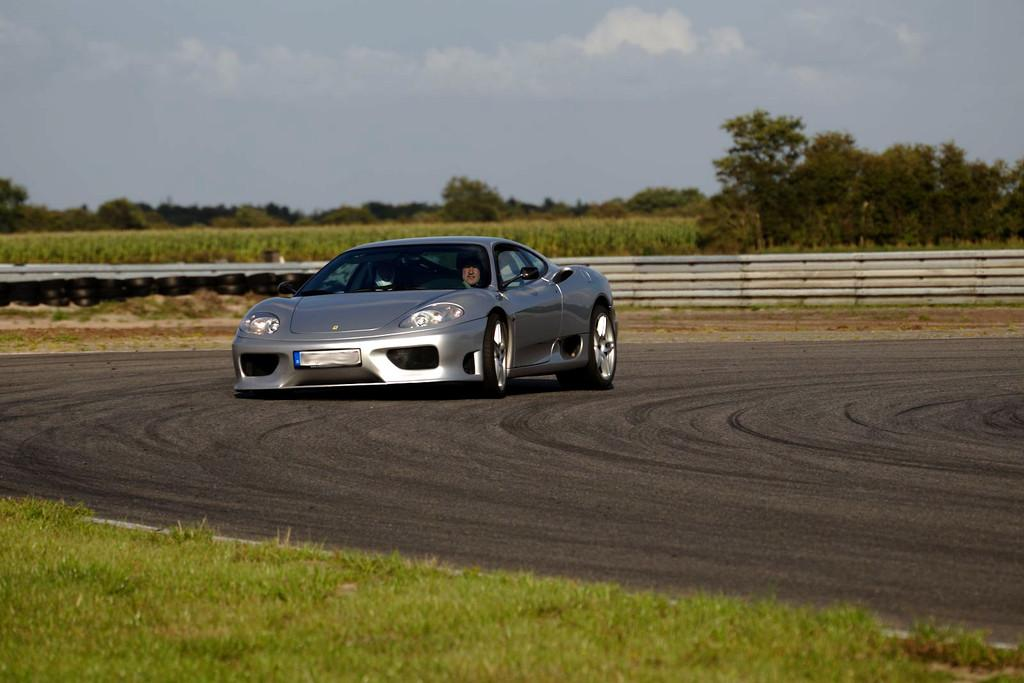What type of surface is on the ground in the image? There is grass on the ground in the image. What type of pathway is present in the image? There is a road in the image. What vehicle can be seen on the road? There is a grey car on the road. What can be seen in the background of the image? There is a railing, trees, and the sky visible in the background of the image. What type of silk is draped over the railing in the image? There is no silk present in the image; it only features a railing, trees, and the sky in the background. What kind of music is being played by the band in the image? There is no band present in the image; it only features a road, a grey car, grass, and background elements. 